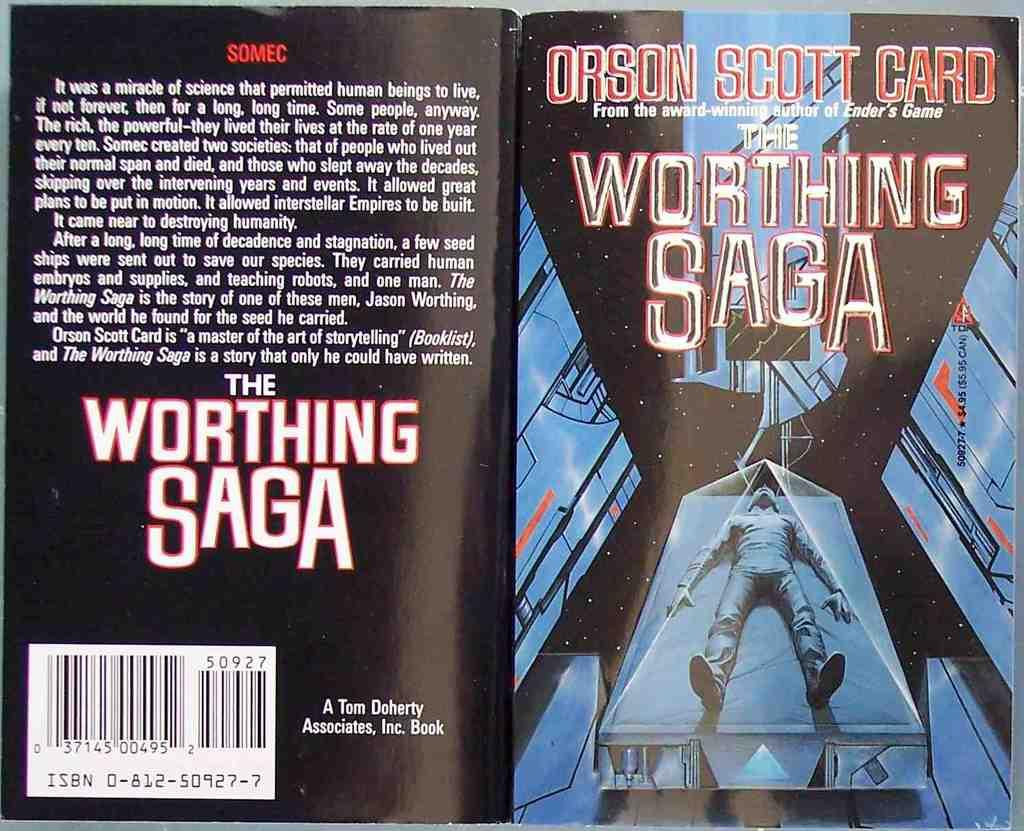<image>
Render a clear and concise summary of the photo. The author who wrote this book is an award winning author. 